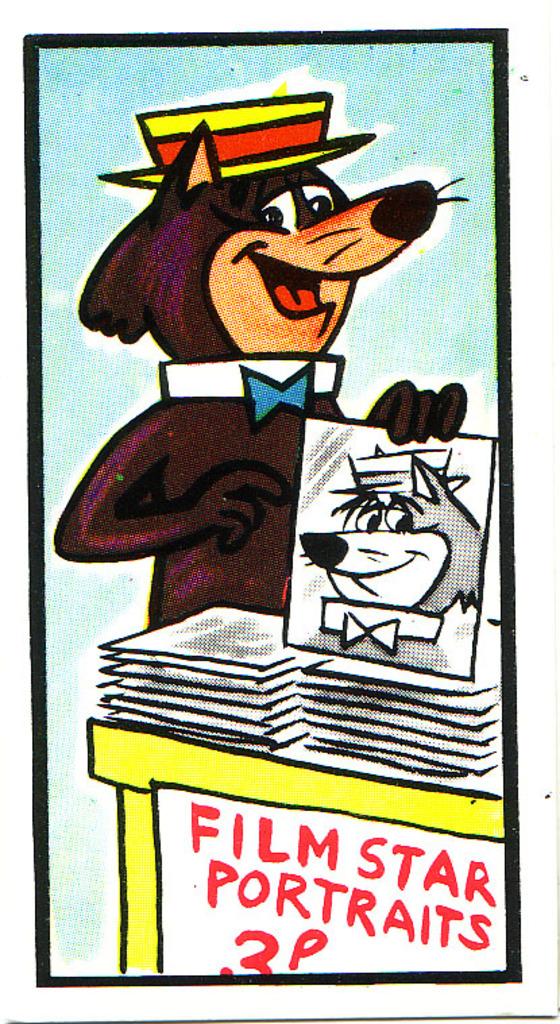What is being sold?
Ensure brevity in your answer.  Film star portraits. How many pence for a portrait?
Make the answer very short. 3. 